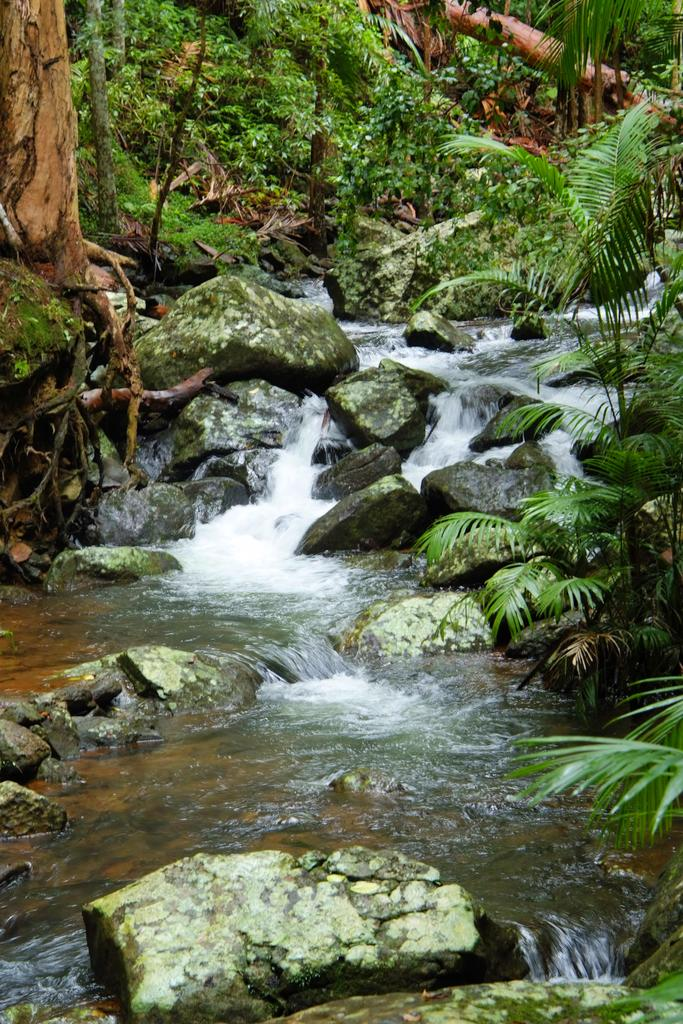What is happening in the image? Water is flowing in the image. What can be seen in the water? There are stones in the water. What is visible in the background of the image? There are trees and plants in the background of the image. What type of collar is being worn by the servant in the image? There is no servant or collar present in the image. 